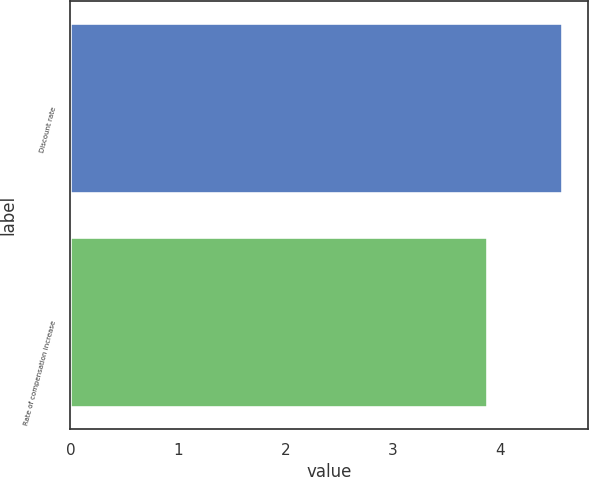Convert chart to OTSL. <chart><loc_0><loc_0><loc_500><loc_500><bar_chart><fcel>Discount rate<fcel>Rate of compensation increase<nl><fcel>4.59<fcel>3.89<nl></chart> 